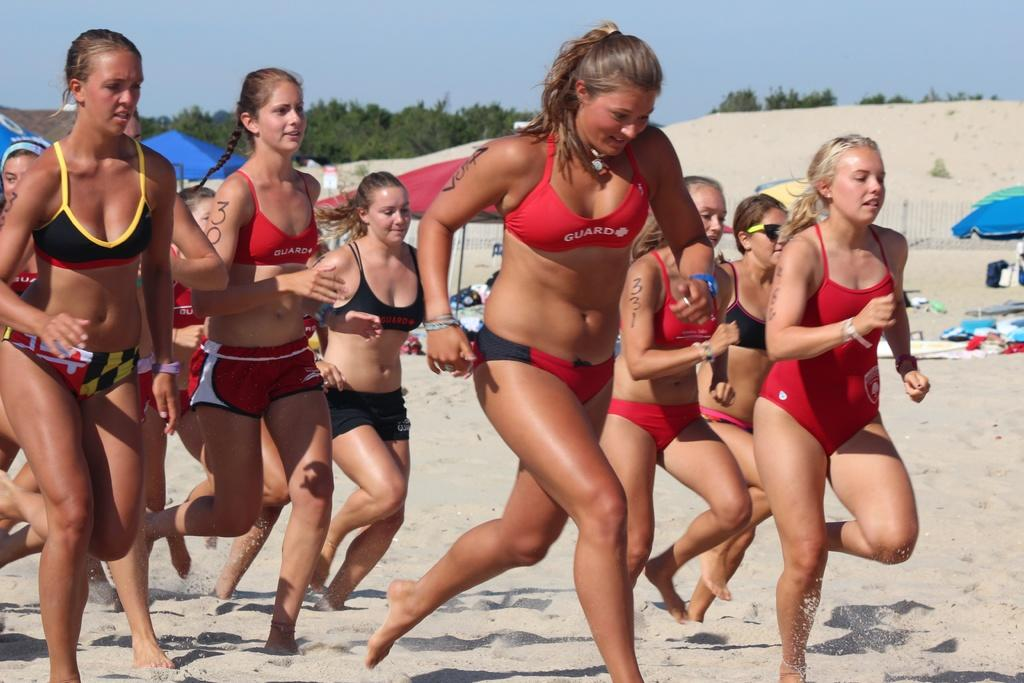<image>
Provide a brief description of the given image. A group of women in Guard bathing suits are running on a beach. 